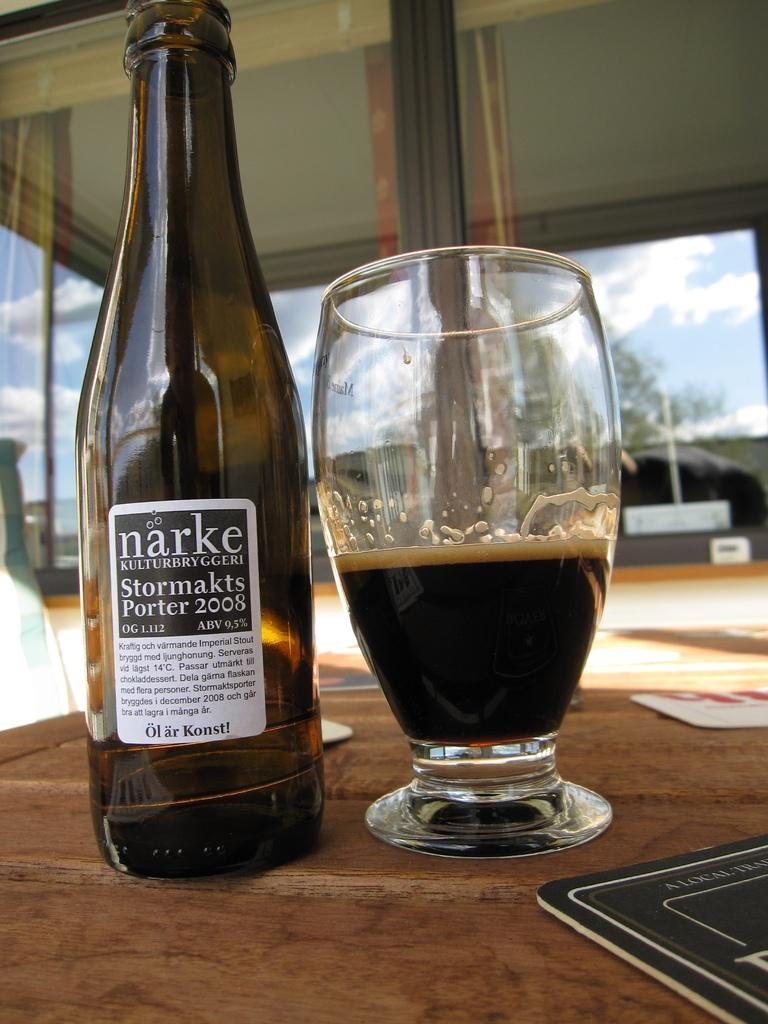<image>
Relay a brief, clear account of the picture shown. A bottle of narke sits next to a half-full glass. 